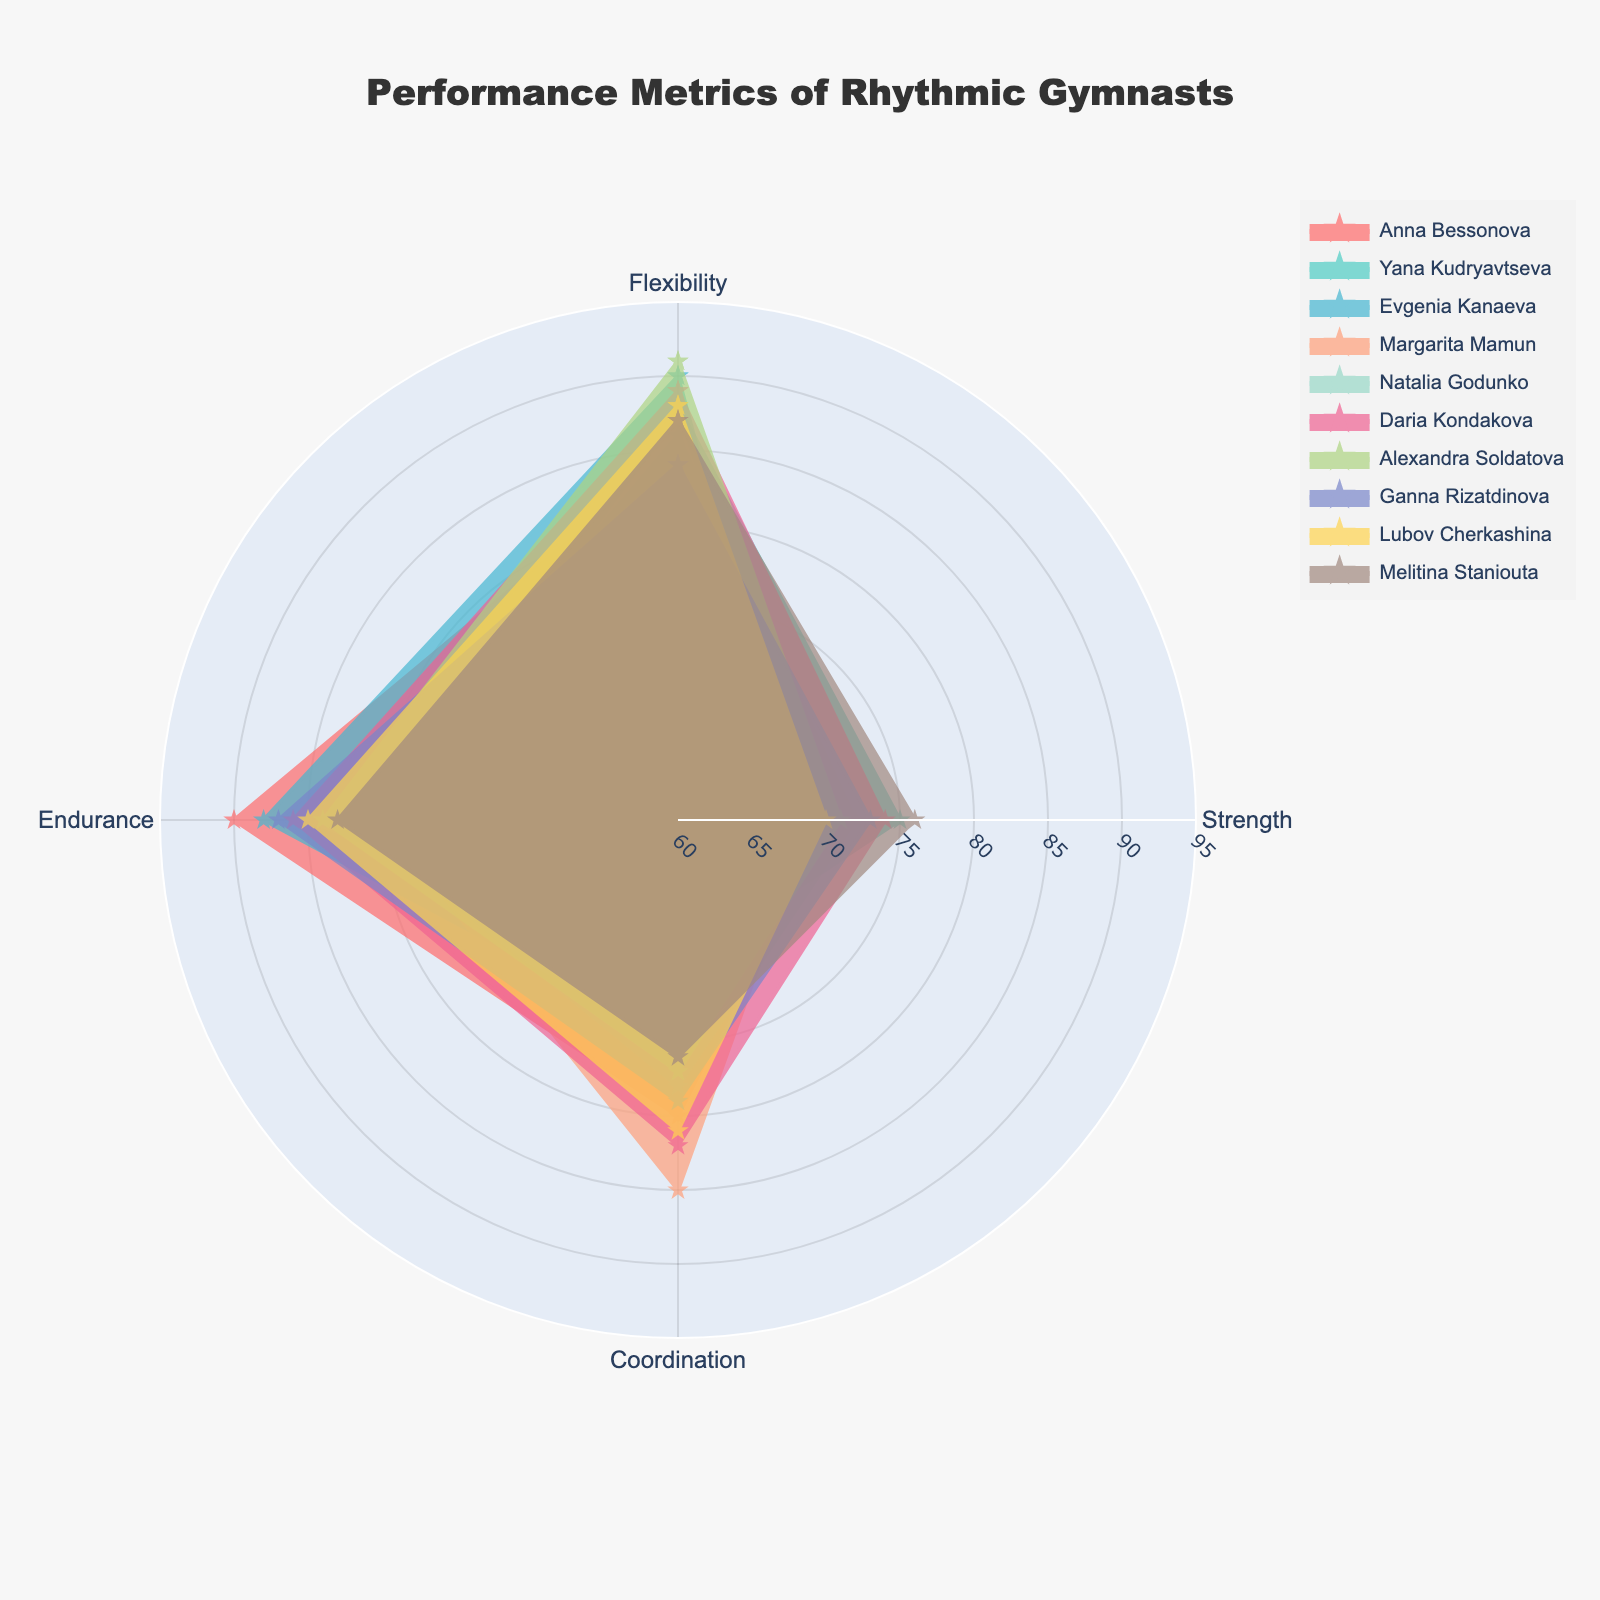What's the title of the figure? The title of the figure is usually displayed at the top and gives a summary of what the figure is about.
Answer: Performance Metrics of Rhythmic Gymnasts What's the color scheme used in the chart? The color scheme in the chart employs various colors to differentiate between gymnasts. Identify by looking at the distinct colors for each gymnast's trace.
Answer: Multiple colors including shades of pink, teal, blue, and yellow Which gymnast shows the highest flexibility? By examining the radial extend in the flexibility segment, find the gymnast who reaches the farthest value on Flexibility.
Answer: Alexandra Soldatova Which gymnast seems to have the most balanced performance across all metrics? Look for the gymnast whose plot traces show closely grouped values around the chart, indicating little variance between metrics.
Answer: Natalia Godunko What's the average Coordination score among all gymnasts? Add the Coordination values for all gymnasts and divide by the total number of gymnasts. (80+70+75+85+78+82+77+79+81+76)/10.
Answer: 78.3 Who has the highest combined score of Flexibility, Strength, and Endurance? Calculate and compare the sum of Flexibility, Strength, and Endurance for each gymnast, identify the highest sum.
Answer: Evgenia Kanaeva (90 + 68 + 88 = 246) Compare the Flexibility scores of Daria Kondakova and Yana Kudryavtseva. Who has a higher score? Check Daria Kondakova's and Yana Kudryavtseva's Flexibility values and compare them. Daria has 89, Yana has 88.
Answer: Daria Kondakova Which metric is the weakest for Anna Bessonova? Examine Anna Bessonova's trace and find the shortest radial extend.
Answer: Strength How does Margarita Mamun's Strength compare to Melitina Staniouta's Strength? Compare their Strength values. Margarita Mamun: 69, Melitina Staniouta: 76.
Answer: Melitina Staniouta's Strength is higher Identify the gymnast with the least Endurance. Look for the smallest radial extent in the Endurance segment.
Answer: Margarita Mamun 